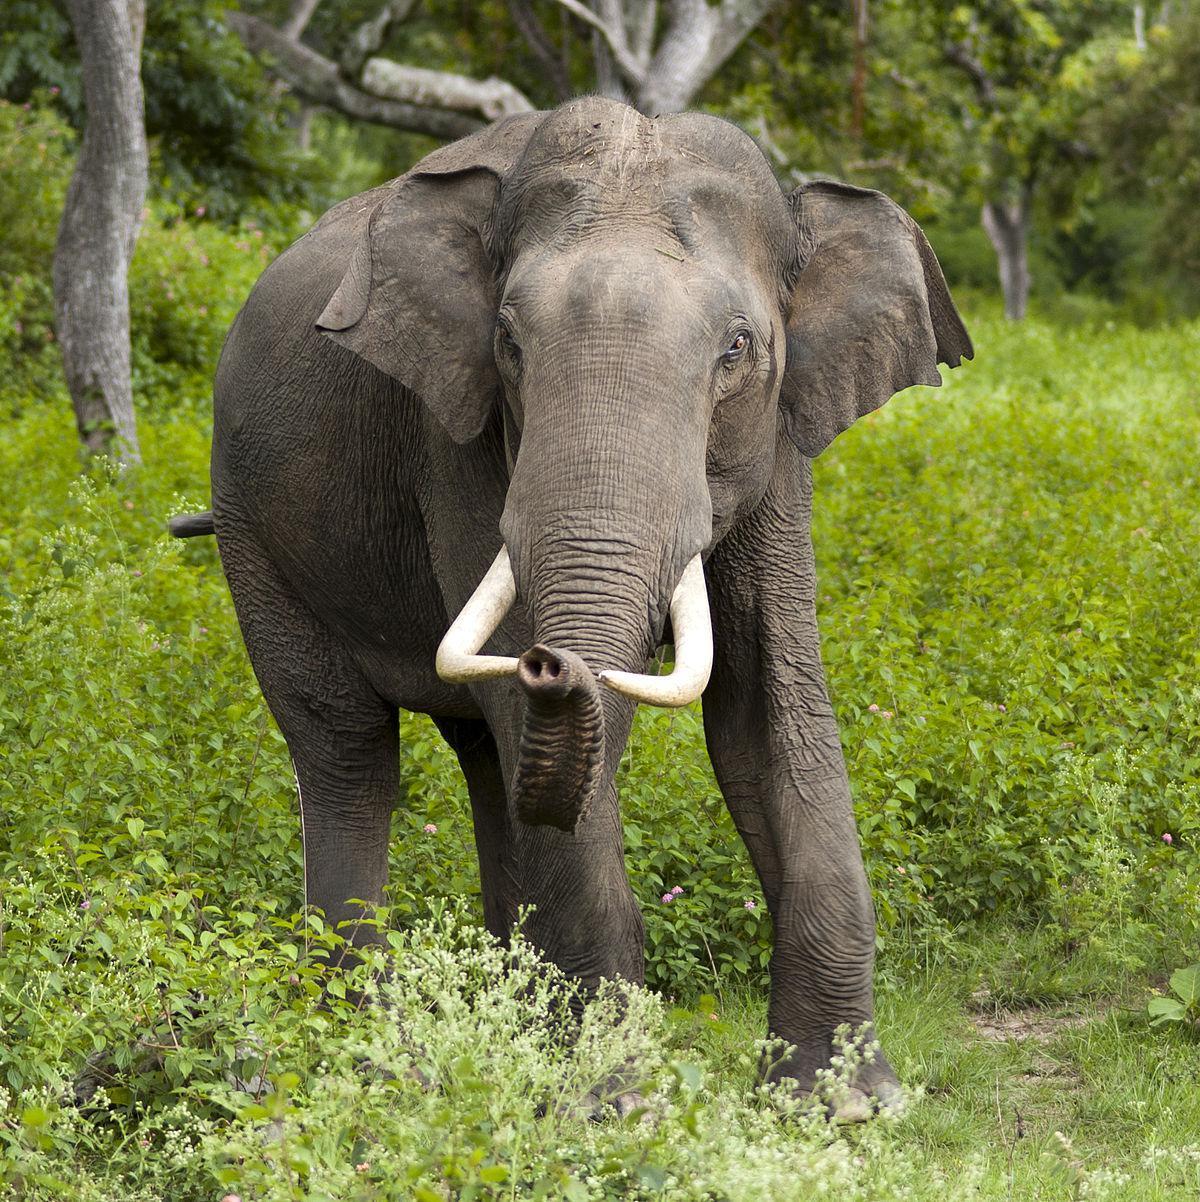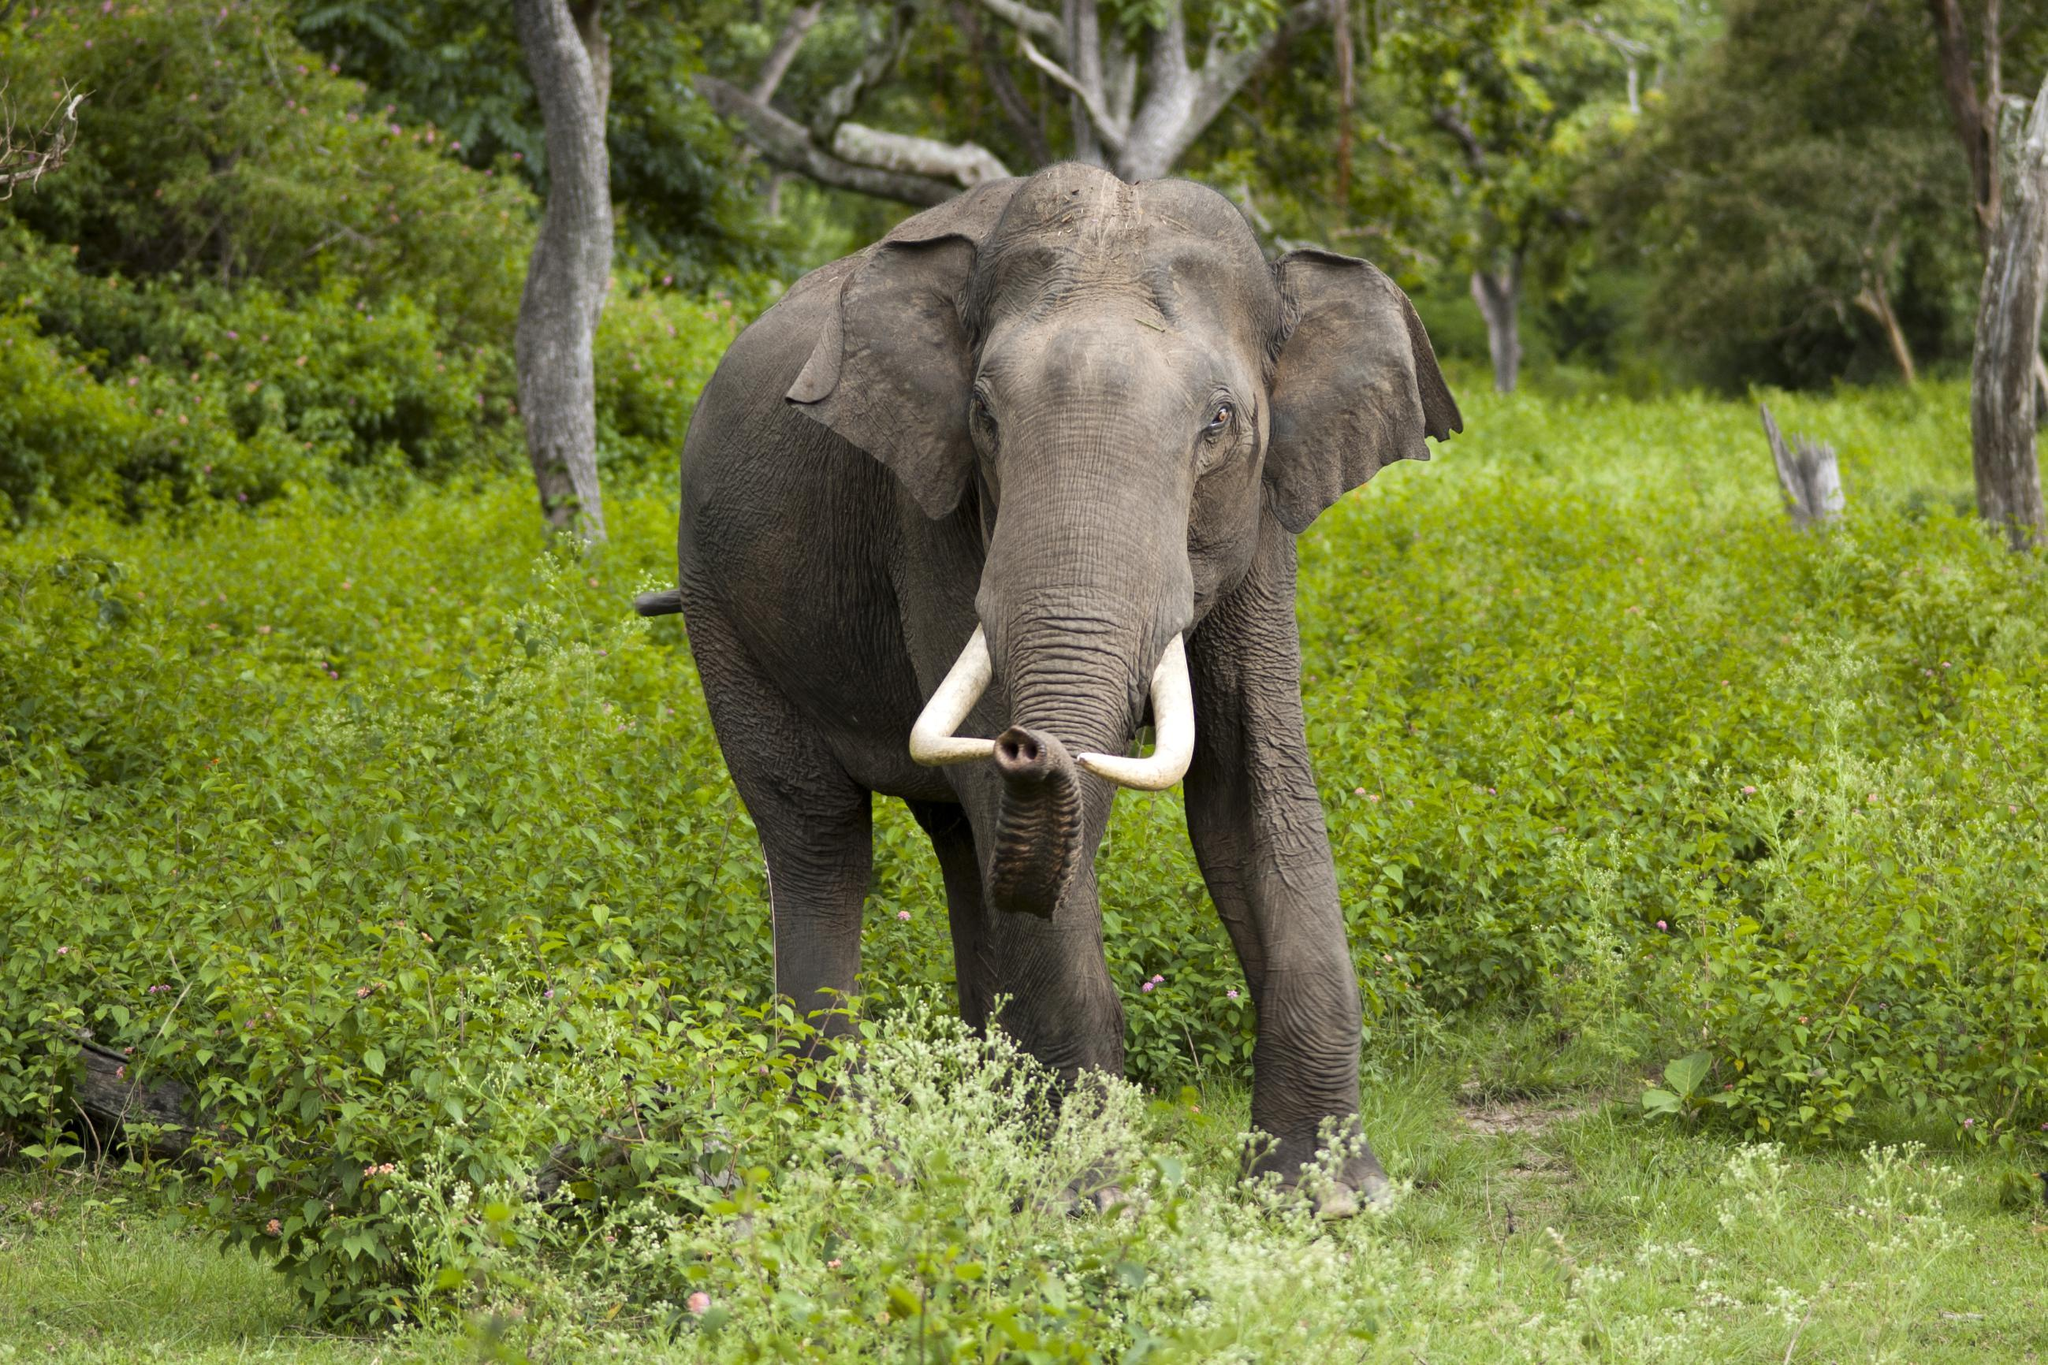The first image is the image on the left, the second image is the image on the right. For the images shown, is this caption "There are two elephants in total." true? Answer yes or no. Yes. 